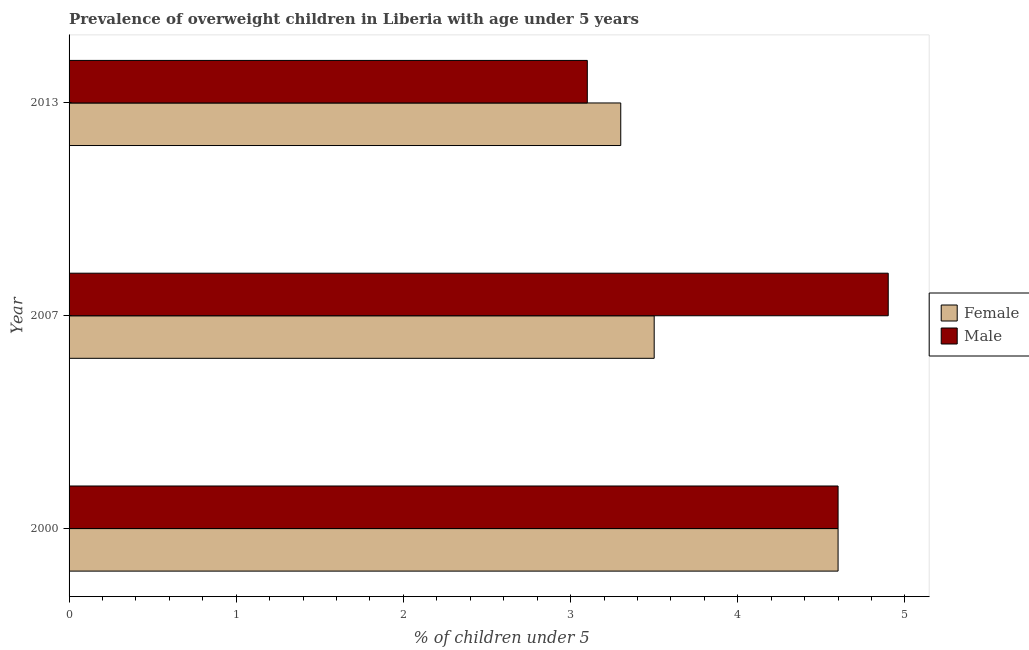How many different coloured bars are there?
Provide a succinct answer. 2. Are the number of bars per tick equal to the number of legend labels?
Ensure brevity in your answer.  Yes. Are the number of bars on each tick of the Y-axis equal?
Your answer should be compact. Yes. What is the percentage of obese female children in 2013?
Provide a short and direct response. 3.3. Across all years, what is the maximum percentage of obese male children?
Give a very brief answer. 4.9. Across all years, what is the minimum percentage of obese female children?
Your answer should be compact. 3.3. In which year was the percentage of obese female children maximum?
Keep it short and to the point. 2000. In which year was the percentage of obese female children minimum?
Your answer should be compact. 2013. What is the total percentage of obese female children in the graph?
Offer a terse response. 11.4. What is the difference between the percentage of obese male children in 2000 and that in 2007?
Give a very brief answer. -0.3. What is the difference between the percentage of obese female children in 2000 and the percentage of obese male children in 2007?
Offer a very short reply. -0.3. What is the ratio of the percentage of obese male children in 2007 to that in 2013?
Keep it short and to the point. 1.58. Is the difference between the percentage of obese male children in 2000 and 2013 greater than the difference between the percentage of obese female children in 2000 and 2013?
Provide a succinct answer. Yes. What is the difference between the highest and the lowest percentage of obese male children?
Your response must be concise. 1.8. Is the sum of the percentage of obese female children in 2007 and 2013 greater than the maximum percentage of obese male children across all years?
Provide a short and direct response. Yes. What does the 1st bar from the top in 2000 represents?
Provide a short and direct response. Male. What does the 2nd bar from the bottom in 2013 represents?
Provide a short and direct response. Male. How many bars are there?
Offer a very short reply. 6. Are all the bars in the graph horizontal?
Your answer should be very brief. Yes. Are the values on the major ticks of X-axis written in scientific E-notation?
Keep it short and to the point. No. Does the graph contain any zero values?
Give a very brief answer. No. Does the graph contain grids?
Make the answer very short. No. Where does the legend appear in the graph?
Ensure brevity in your answer.  Center right. How many legend labels are there?
Make the answer very short. 2. What is the title of the graph?
Your response must be concise. Prevalence of overweight children in Liberia with age under 5 years. Does "International Visitors" appear as one of the legend labels in the graph?
Ensure brevity in your answer.  No. What is the label or title of the X-axis?
Your response must be concise.  % of children under 5. What is the  % of children under 5 of Female in 2000?
Your response must be concise. 4.6. What is the  % of children under 5 of Male in 2000?
Keep it short and to the point. 4.6. What is the  % of children under 5 in Male in 2007?
Your answer should be compact. 4.9. What is the  % of children under 5 in Female in 2013?
Give a very brief answer. 3.3. What is the  % of children under 5 in Male in 2013?
Ensure brevity in your answer.  3.1. Across all years, what is the maximum  % of children under 5 in Female?
Your response must be concise. 4.6. Across all years, what is the maximum  % of children under 5 of Male?
Your answer should be very brief. 4.9. Across all years, what is the minimum  % of children under 5 in Female?
Offer a very short reply. 3.3. Across all years, what is the minimum  % of children under 5 in Male?
Ensure brevity in your answer.  3.1. What is the difference between the  % of children under 5 of Female in 2000 and that in 2007?
Your answer should be compact. 1.1. What is the difference between the  % of children under 5 in Male in 2000 and that in 2013?
Provide a succinct answer. 1.5. What is the difference between the  % of children under 5 of Female in 2007 and that in 2013?
Ensure brevity in your answer.  0.2. What is the difference between the  % of children under 5 in Female in 2000 and the  % of children under 5 in Male in 2013?
Ensure brevity in your answer.  1.5. What is the average  % of children under 5 of Male per year?
Give a very brief answer. 4.2. In the year 2000, what is the difference between the  % of children under 5 of Female and  % of children under 5 of Male?
Offer a very short reply. 0. What is the ratio of the  % of children under 5 in Female in 2000 to that in 2007?
Provide a short and direct response. 1.31. What is the ratio of the  % of children under 5 of Male in 2000 to that in 2007?
Your response must be concise. 0.94. What is the ratio of the  % of children under 5 in Female in 2000 to that in 2013?
Your response must be concise. 1.39. What is the ratio of the  % of children under 5 in Male in 2000 to that in 2013?
Offer a terse response. 1.48. What is the ratio of the  % of children under 5 in Female in 2007 to that in 2013?
Offer a terse response. 1.06. What is the ratio of the  % of children under 5 of Male in 2007 to that in 2013?
Offer a very short reply. 1.58. What is the difference between the highest and the second highest  % of children under 5 of Female?
Keep it short and to the point. 1.1. What is the difference between the highest and the second highest  % of children under 5 of Male?
Keep it short and to the point. 0.3. What is the difference between the highest and the lowest  % of children under 5 of Female?
Give a very brief answer. 1.3. 